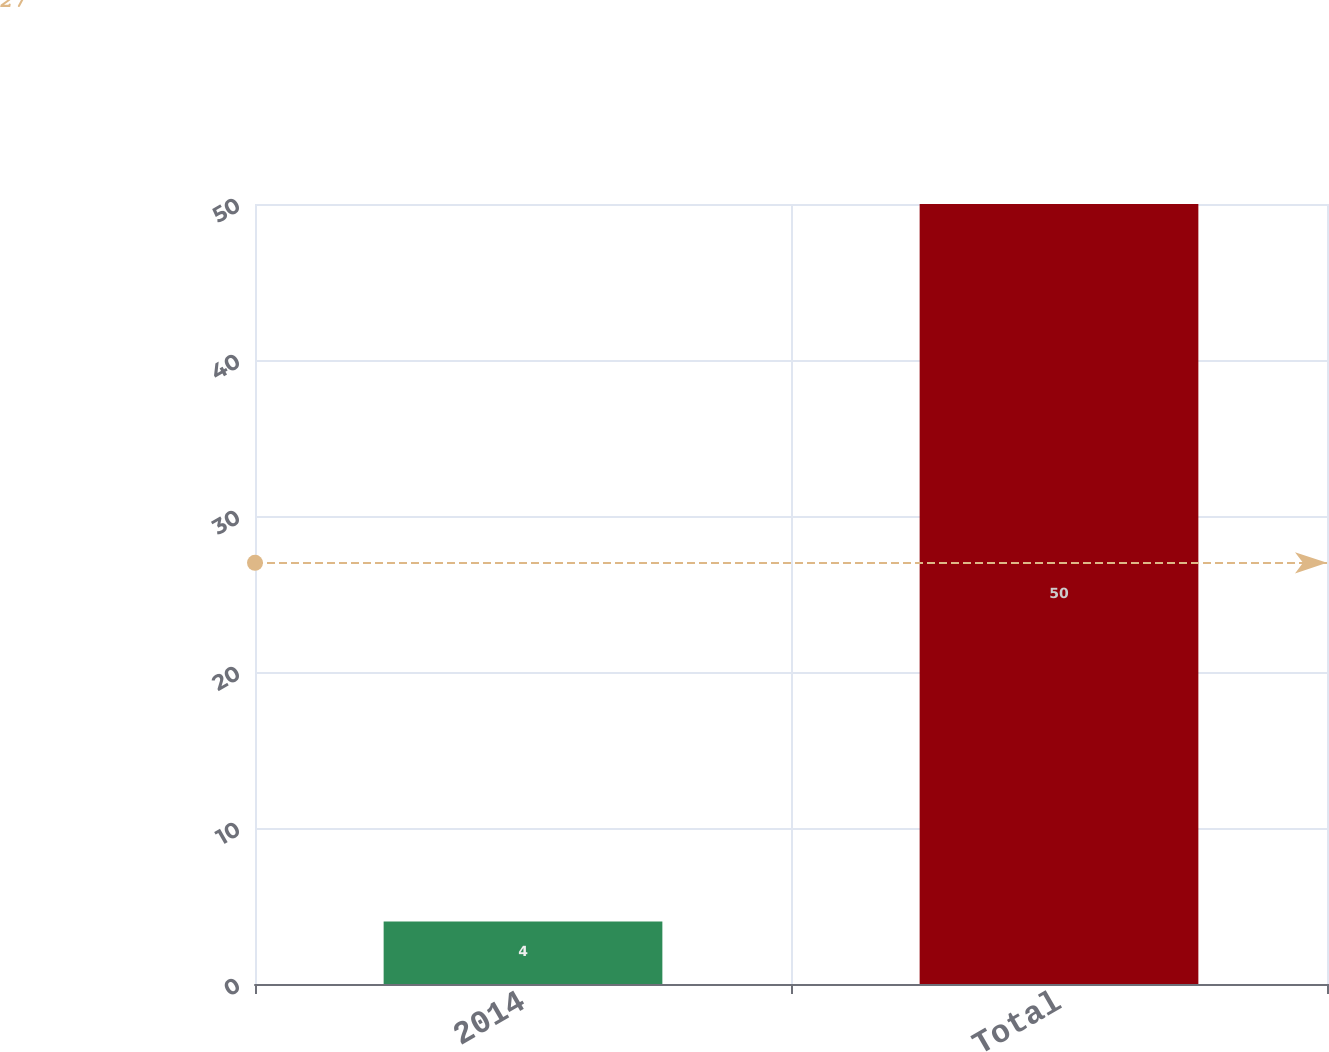<chart> <loc_0><loc_0><loc_500><loc_500><bar_chart><fcel>2014<fcel>Total<nl><fcel>4<fcel>50<nl></chart> 